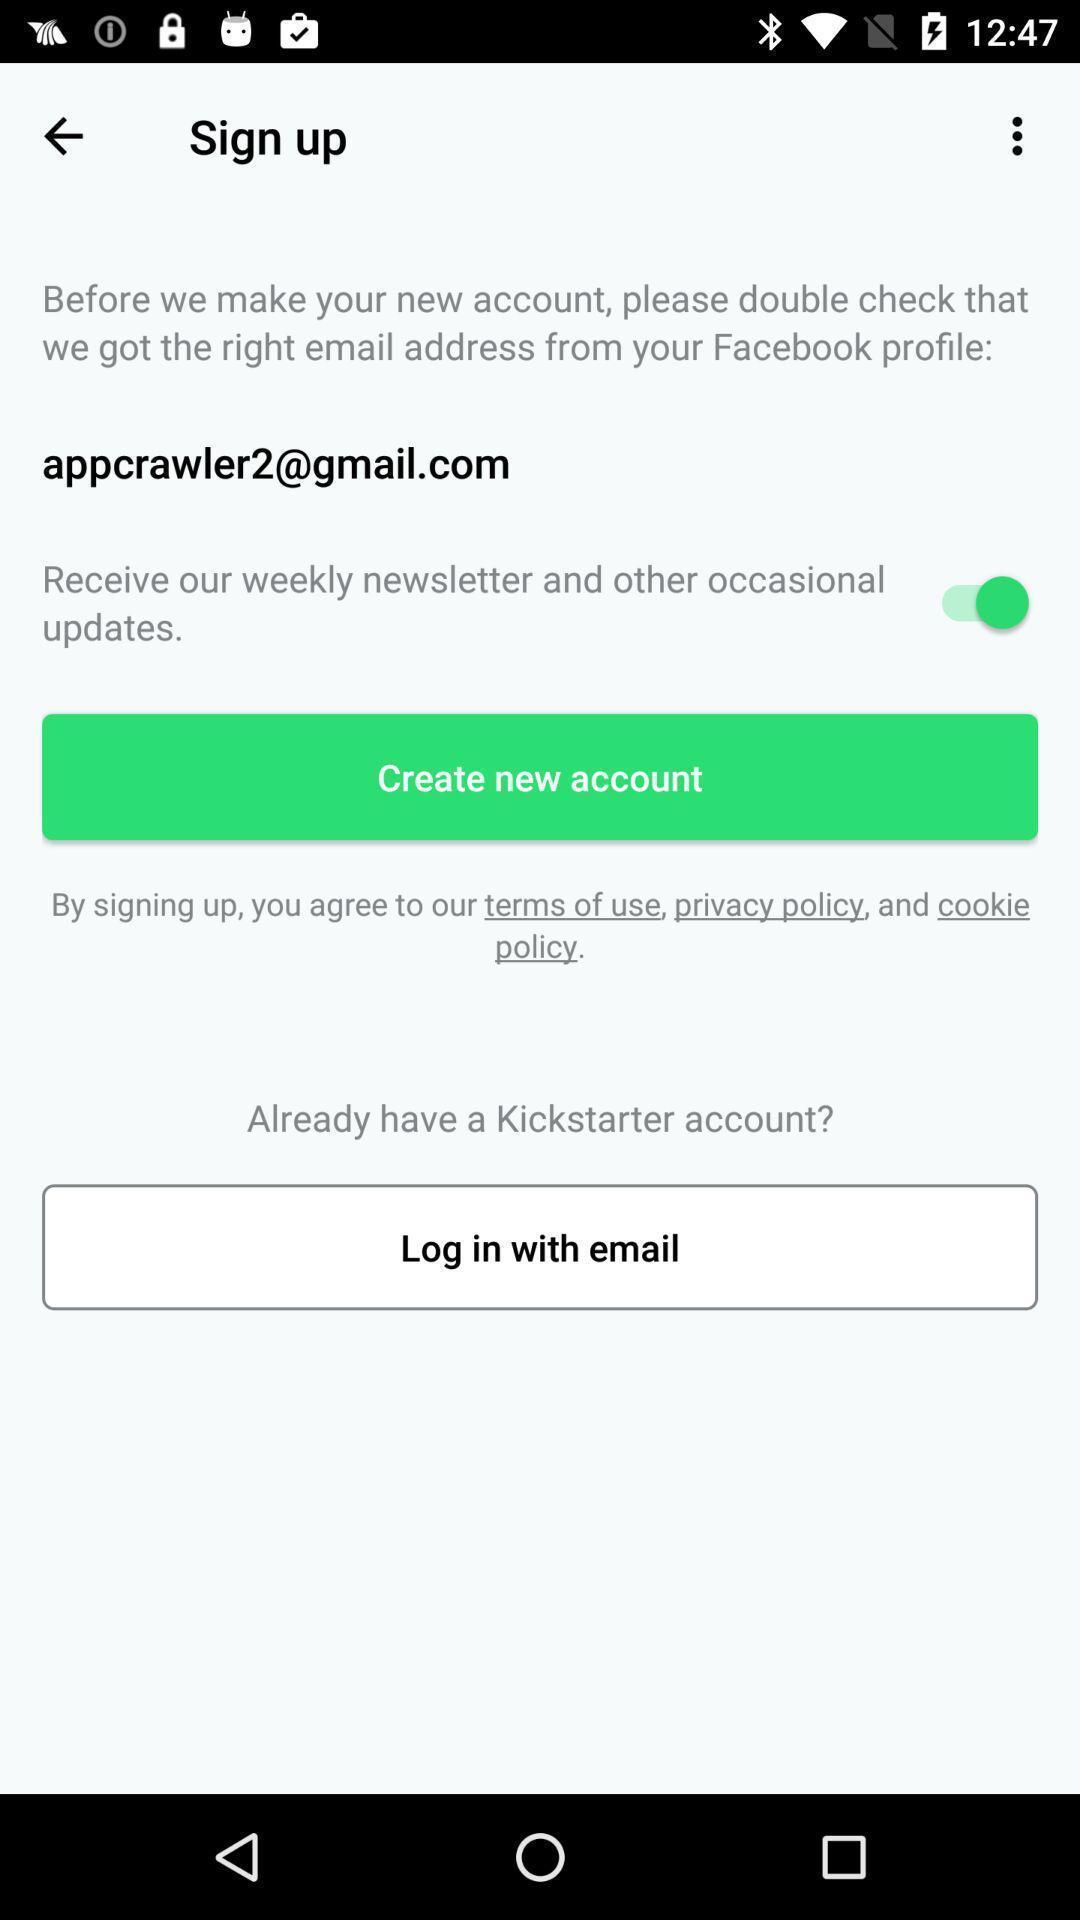Explain the elements present in this screenshot. Sign up page. 